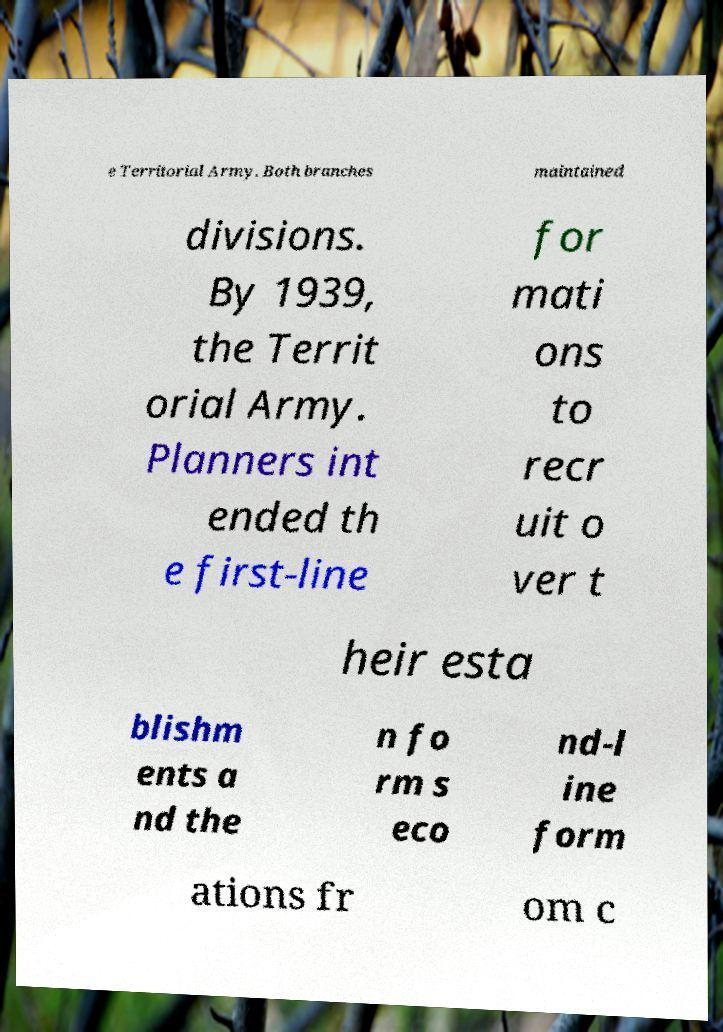There's text embedded in this image that I need extracted. Can you transcribe it verbatim? e Territorial Army. Both branches maintained divisions. By 1939, the Territ orial Army. Planners int ended th e first-line for mati ons to recr uit o ver t heir esta blishm ents a nd the n fo rm s eco nd-l ine form ations fr om c 